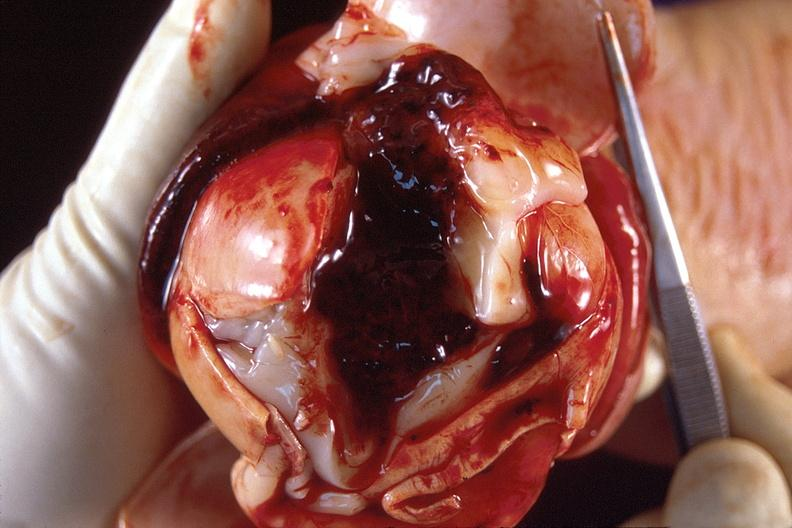what does this image show?
Answer the question using a single word or phrase. Brain 